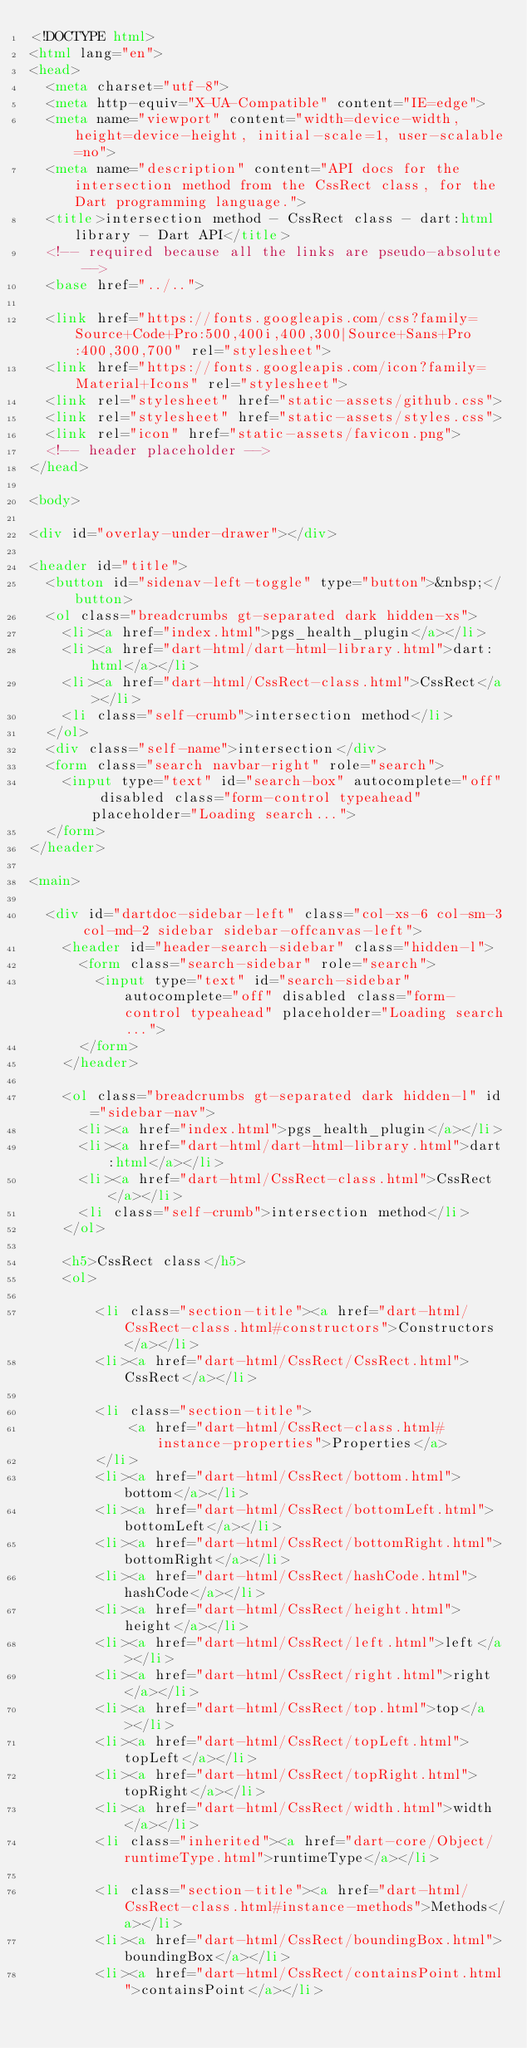<code> <loc_0><loc_0><loc_500><loc_500><_HTML_><!DOCTYPE html>
<html lang="en">
<head>
  <meta charset="utf-8">
  <meta http-equiv="X-UA-Compatible" content="IE=edge">
  <meta name="viewport" content="width=device-width, height=device-height, initial-scale=1, user-scalable=no">
  <meta name="description" content="API docs for the intersection method from the CssRect class, for the Dart programming language.">
  <title>intersection method - CssRect class - dart:html library - Dart API</title>
  <!-- required because all the links are pseudo-absolute -->
  <base href="../..">

  <link href="https://fonts.googleapis.com/css?family=Source+Code+Pro:500,400i,400,300|Source+Sans+Pro:400,300,700" rel="stylesheet">
  <link href="https://fonts.googleapis.com/icon?family=Material+Icons" rel="stylesheet">
  <link rel="stylesheet" href="static-assets/github.css">
  <link rel="stylesheet" href="static-assets/styles.css">
  <link rel="icon" href="static-assets/favicon.png">
  <!-- header placeholder -->
</head>

<body>

<div id="overlay-under-drawer"></div>

<header id="title">
  <button id="sidenav-left-toggle" type="button">&nbsp;</button>
  <ol class="breadcrumbs gt-separated dark hidden-xs">
    <li><a href="index.html">pgs_health_plugin</a></li>
    <li><a href="dart-html/dart-html-library.html">dart:html</a></li>
    <li><a href="dart-html/CssRect-class.html">CssRect</a></li>
    <li class="self-crumb">intersection method</li>
  </ol>
  <div class="self-name">intersection</div>
  <form class="search navbar-right" role="search">
    <input type="text" id="search-box" autocomplete="off" disabled class="form-control typeahead" placeholder="Loading search...">
  </form>
</header>

<main>

  <div id="dartdoc-sidebar-left" class="col-xs-6 col-sm-3 col-md-2 sidebar sidebar-offcanvas-left">
    <header id="header-search-sidebar" class="hidden-l">
      <form class="search-sidebar" role="search">
        <input type="text" id="search-sidebar" autocomplete="off" disabled class="form-control typeahead" placeholder="Loading search...">
      </form>
    </header>
    
    <ol class="breadcrumbs gt-separated dark hidden-l" id="sidebar-nav">
      <li><a href="index.html">pgs_health_plugin</a></li>
      <li><a href="dart-html/dart-html-library.html">dart:html</a></li>
      <li><a href="dart-html/CssRect-class.html">CssRect</a></li>
      <li class="self-crumb">intersection method</li>
    </ol>
    
    <h5>CssRect class</h5>
    <ol>
    
        <li class="section-title"><a href="dart-html/CssRect-class.html#constructors">Constructors</a></li>
        <li><a href="dart-html/CssRect/CssRect.html">CssRect</a></li>
    
        <li class="section-title">
            <a href="dart-html/CssRect-class.html#instance-properties">Properties</a>
        </li>
        <li><a href="dart-html/CssRect/bottom.html">bottom</a></li>
        <li><a href="dart-html/CssRect/bottomLeft.html">bottomLeft</a></li>
        <li><a href="dart-html/CssRect/bottomRight.html">bottomRight</a></li>
        <li><a href="dart-html/CssRect/hashCode.html">hashCode</a></li>
        <li><a href="dart-html/CssRect/height.html">height</a></li>
        <li><a href="dart-html/CssRect/left.html">left</a></li>
        <li><a href="dart-html/CssRect/right.html">right</a></li>
        <li><a href="dart-html/CssRect/top.html">top</a></li>
        <li><a href="dart-html/CssRect/topLeft.html">topLeft</a></li>
        <li><a href="dart-html/CssRect/topRight.html">topRight</a></li>
        <li><a href="dart-html/CssRect/width.html">width</a></li>
        <li class="inherited"><a href="dart-core/Object/runtimeType.html">runtimeType</a></li>
    
        <li class="section-title"><a href="dart-html/CssRect-class.html#instance-methods">Methods</a></li>
        <li><a href="dart-html/CssRect/boundingBox.html">boundingBox</a></li>
        <li><a href="dart-html/CssRect/containsPoint.html">containsPoint</a></li></code> 